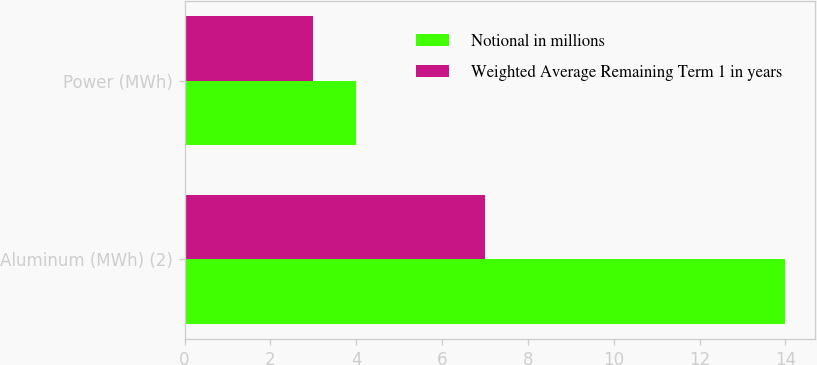<chart> <loc_0><loc_0><loc_500><loc_500><stacked_bar_chart><ecel><fcel>Aluminum (MWh) (2)<fcel>Power (MWh)<nl><fcel>Notional in millions<fcel>14<fcel>4<nl><fcel>Weighted Average Remaining Term 1 in years<fcel>7<fcel>3<nl></chart> 